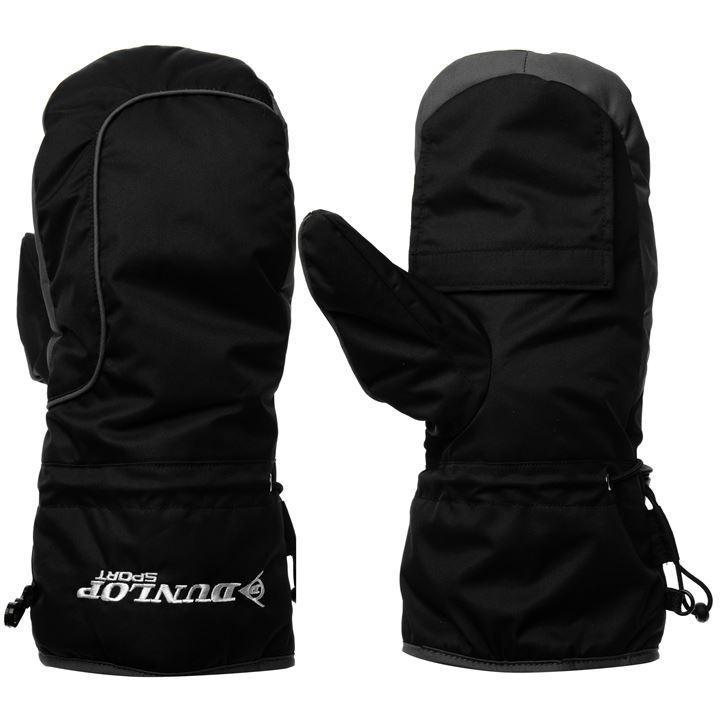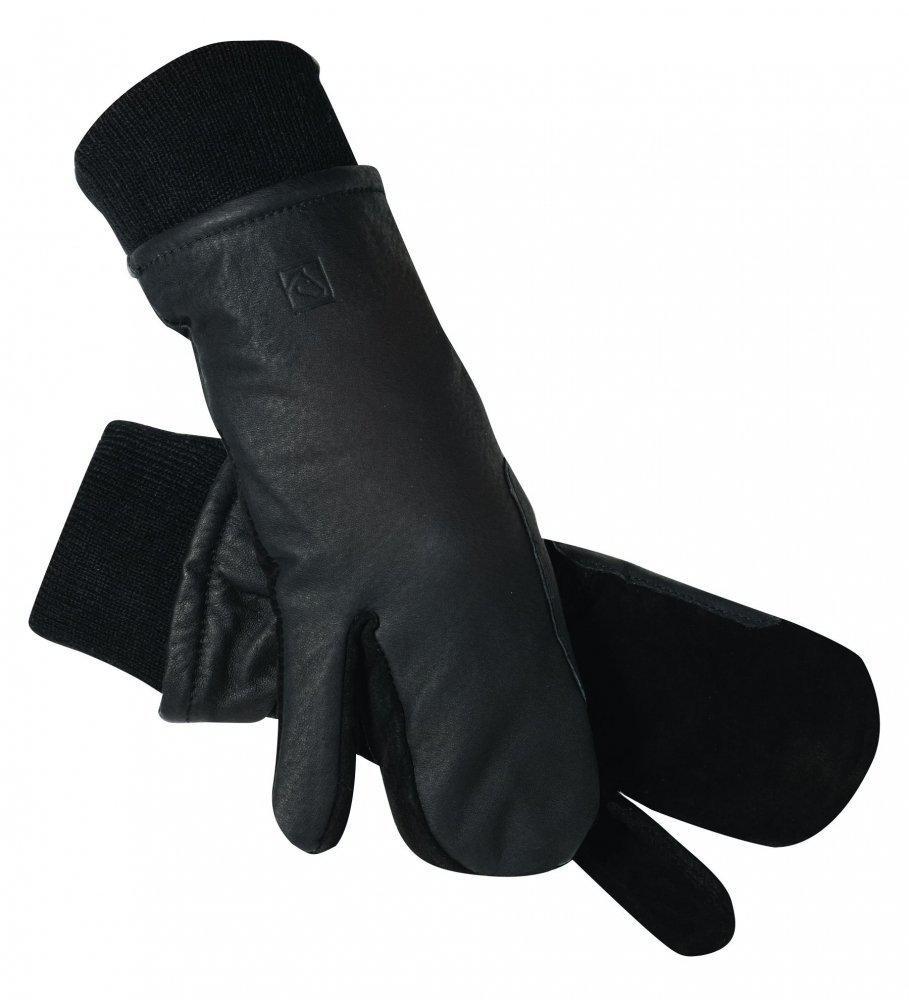The first image is the image on the left, the second image is the image on the right. Considering the images on both sides, is "The left image contains one pair of mittens displayed with the cuff end up, and the right image features a pair of half-finger gloves with a mitten flap." valid? Answer yes or no. No. The first image is the image on the left, the second image is the image on the right. Assess this claim about the two images: "One of the pairs of mittens is the open-fingered style.". Correct or not? Answer yes or no. No. The first image is the image on the left, the second image is the image on the right. Evaluate the accuracy of this statement regarding the images: "Some of the mittens or gloves are furry and none of them are being worn.". Is it true? Answer yes or no. No. The first image is the image on the left, the second image is the image on the right. Considering the images on both sides, is "The right image contains two finger less gloves." valid? Answer yes or no. No. 